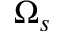<formula> <loc_0><loc_0><loc_500><loc_500>\Omega _ { s }</formula> 